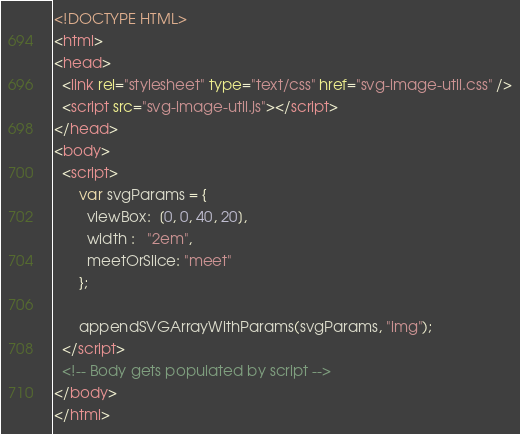Convert code to text. <code><loc_0><loc_0><loc_500><loc_500><_HTML_><!DOCTYPE HTML>
<html>
<head>
  <link rel="stylesheet" type="text/css" href="svg-image-util.css" />
  <script src="svg-image-util.js"></script>
</head>
<body>
  <script>
      var svgParams = {
        viewBox:  [0, 0, 40, 20],
        width :   "2em",
        meetOrSlice: "meet"
      };

      appendSVGArrayWithParams(svgParams, "img");
  </script>
  <!-- Body gets populated by script -->
</body>
</html>
</code> 